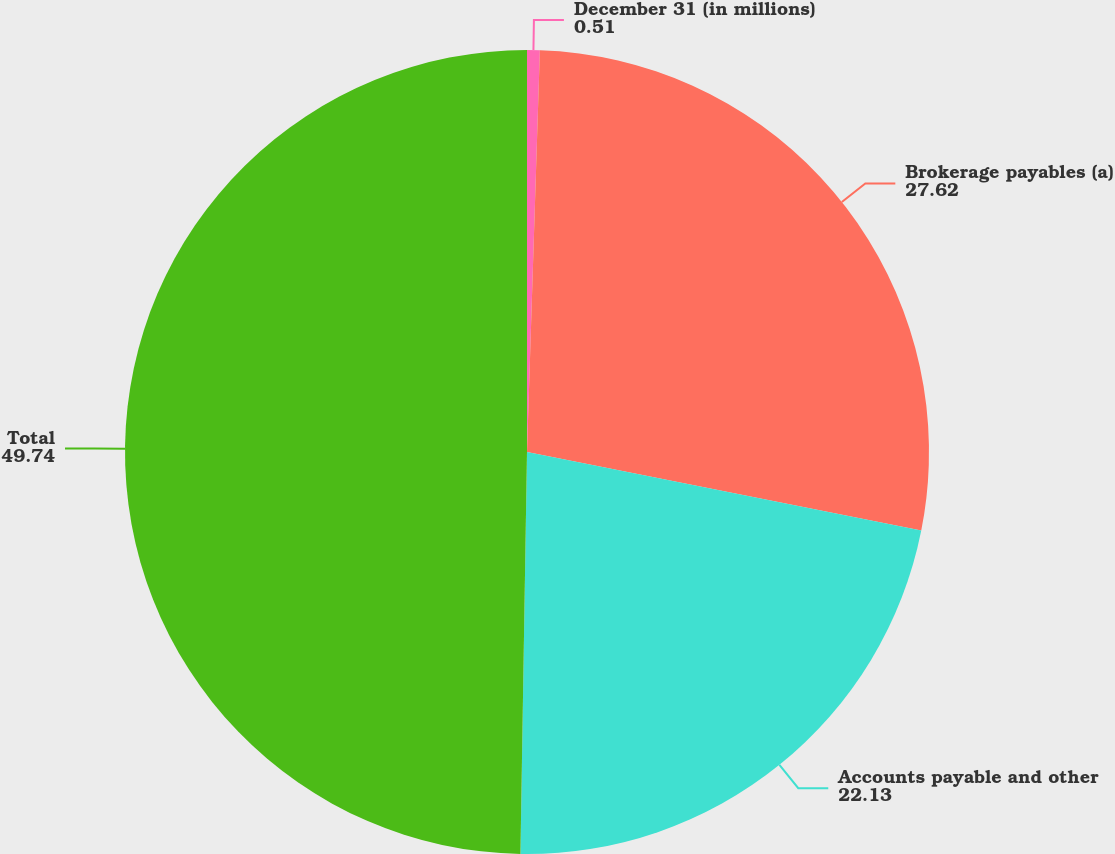Convert chart. <chart><loc_0><loc_0><loc_500><loc_500><pie_chart><fcel>December 31 (in millions)<fcel>Brokerage payables (a)<fcel>Accounts payable and other<fcel>Total<nl><fcel>0.51%<fcel>27.62%<fcel>22.13%<fcel>49.74%<nl></chart> 